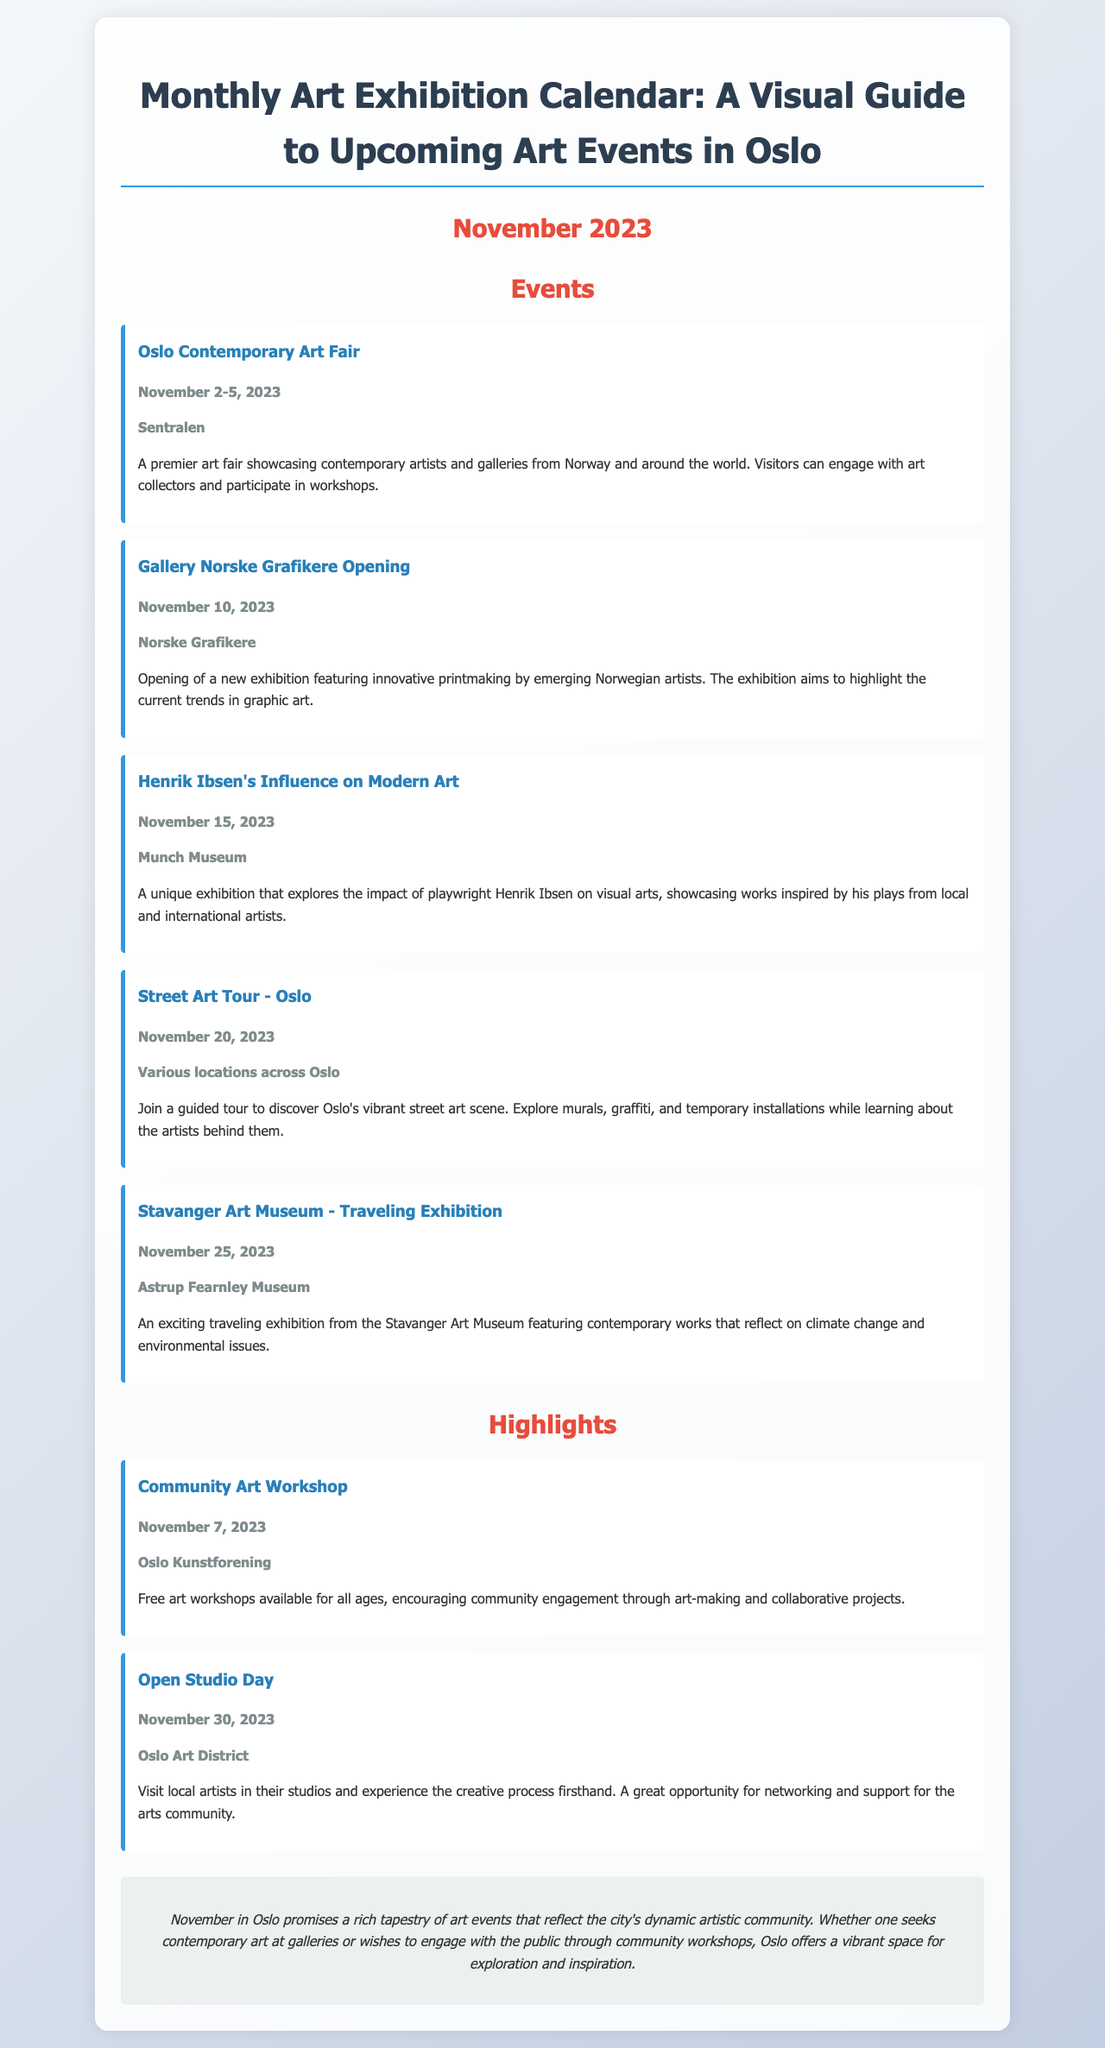What is the date of the Oslo Contemporary Art Fair? The date is specified in the document as November 2-5, 2023.
Answer: November 2-5, 2023 Where is the Gallery Norske Grafikere Opening held? The document indicates that it is held at Norske Grafikere.
Answer: Norske Grafikere Which exhibition explores Henrik Ibsen's influence? The document lists "Henrik Ibsen's Influence on Modern Art" as the exhibition exploring this theme.
Answer: Henrik Ibsen's Influence on Modern Art What type of event is scheduled for November 7, 2023? The document describes it as a Community Art Workshop, indicating the nature of the event.
Answer: Community Art Workshop How many days does the Oslo Contemporary Art Fair last? The event spans four days as indicated by its start and end dates.
Answer: Four days What is the main theme of the Stavanger Art Museum traveling exhibition? The document notes that it reflects on climate change and environmental issues.
Answer: Climate change and environmental issues When is the Open Studio Day taking place? The date for the Open Studio Day is mentioned as November 30, 2023.
Answer: November 30, 2023 What type of activities are featured in the Street Art Tour? The activities include discovering murals, graffiti, and temporary installations in Oslo.
Answer: Murals, graffiti, and temporary installations What is the conclusion's overall impression of November events in Oslo? The document states that November in Oslo promises a rich tapestry of art events.
Answer: Rich tapestry of art events 